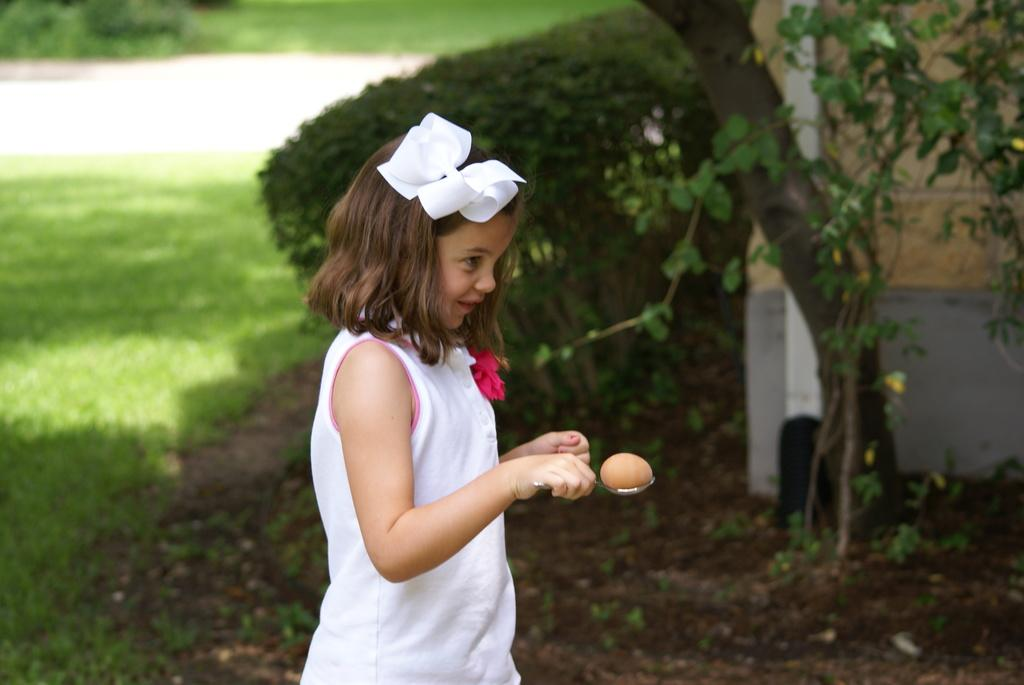Who is the main subject in the image? There is a girl in the image. What is the girl holding in the image? The girl is holding a spoon with an egg in the image. What type of vegetation can be seen in the image? There is grass, plants, and a tree visible in the image. What is the background of the image composed of? The background of the image includes grass and plants. What advice does the girl's grandmother give her in the image? There is no grandmother present in the image, so it is not possible to answer that question. 